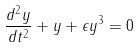Convert formula to latex. <formula><loc_0><loc_0><loc_500><loc_500>\frac { d ^ { 2 } y } { d t ^ { 2 } } + y + \epsilon y ^ { 3 } = 0</formula> 